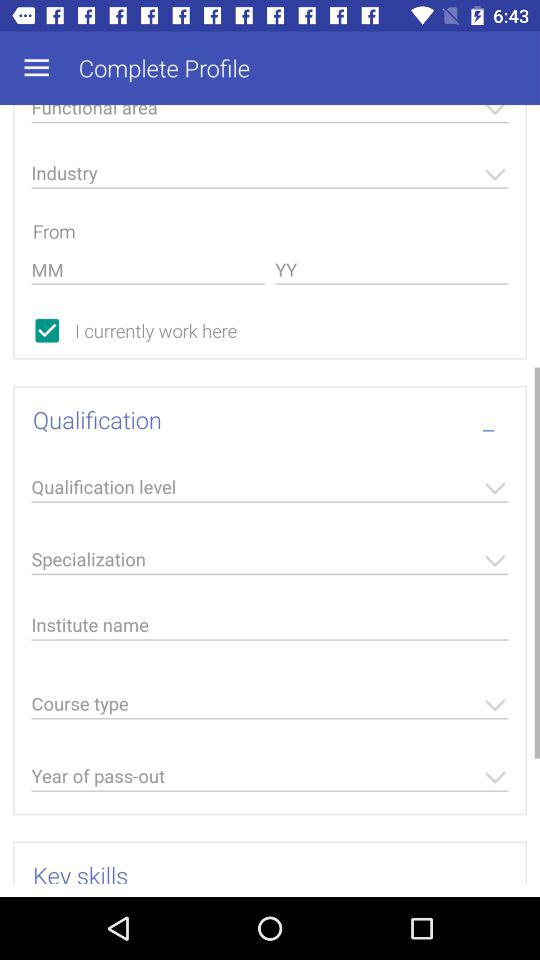How many text input fields are there in the 'Experience' section?
Answer the question using a single word or phrase. 2 